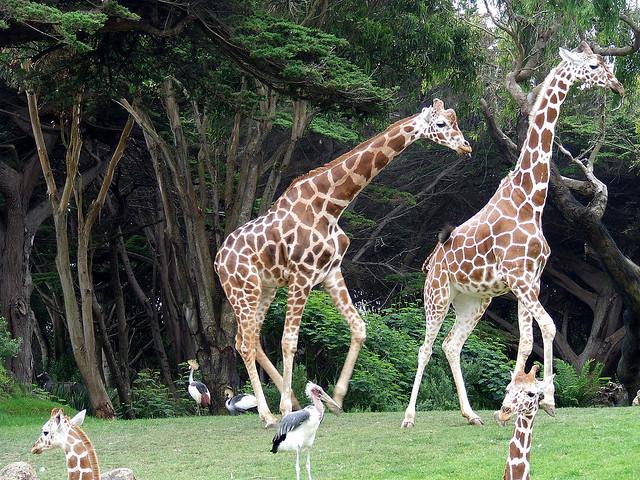Are these giraffes?
Short answer required. Yes. What kind of birds are these?
Concise answer only. Pelican. How many giraffes?
Answer briefly. 4. 